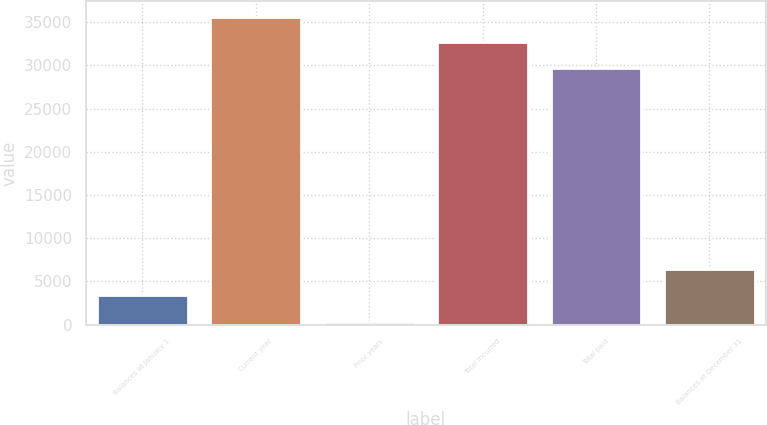<chart> <loc_0><loc_0><loc_500><loc_500><bar_chart><fcel>Balances at January 1<fcel>Current year<fcel>Prior years<fcel>Total incurred<fcel>Total paid<fcel>Balances at December 31<nl><fcel>3415<fcel>35635.2<fcel>257<fcel>32641.1<fcel>29647<fcel>6409.1<nl></chart> 